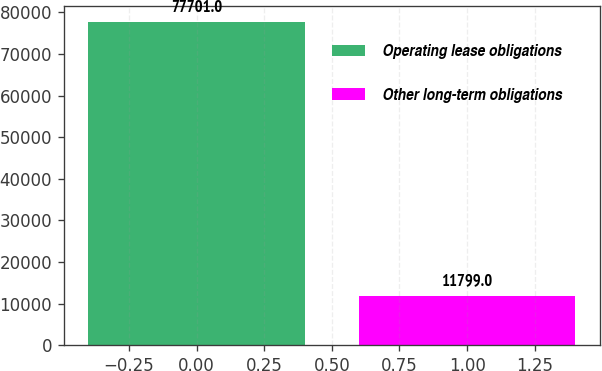Convert chart to OTSL. <chart><loc_0><loc_0><loc_500><loc_500><bar_chart><fcel>Operating lease obligations<fcel>Other long-term obligations<nl><fcel>77701<fcel>11799<nl></chart> 